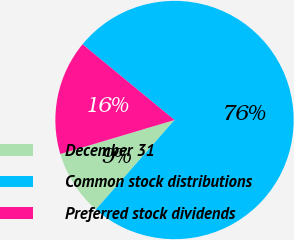Convert chart. <chart><loc_0><loc_0><loc_500><loc_500><pie_chart><fcel>December 31<fcel>Common stock distributions<fcel>Preferred stock dividends<nl><fcel>8.91%<fcel>75.51%<fcel>15.57%<nl></chart> 